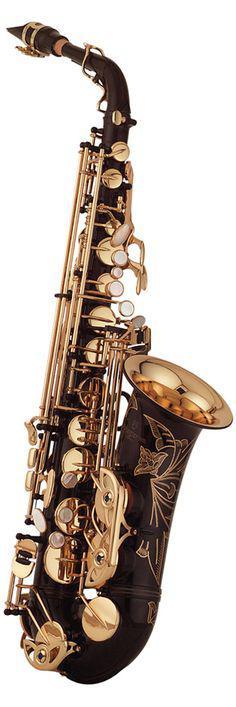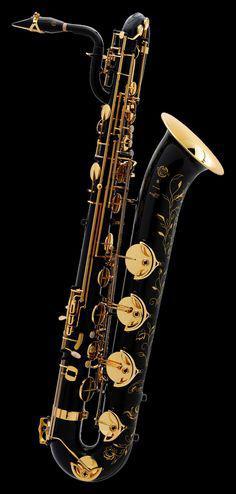The first image is the image on the left, the second image is the image on the right. Analyze the images presented: Is the assertion "The entire length of one saxophone is shown in each image." valid? Answer yes or no. Yes. The first image is the image on the left, the second image is the image on the right. For the images shown, is this caption "Each image shows a single upright instrument on a plain background." true? Answer yes or no. Yes. 